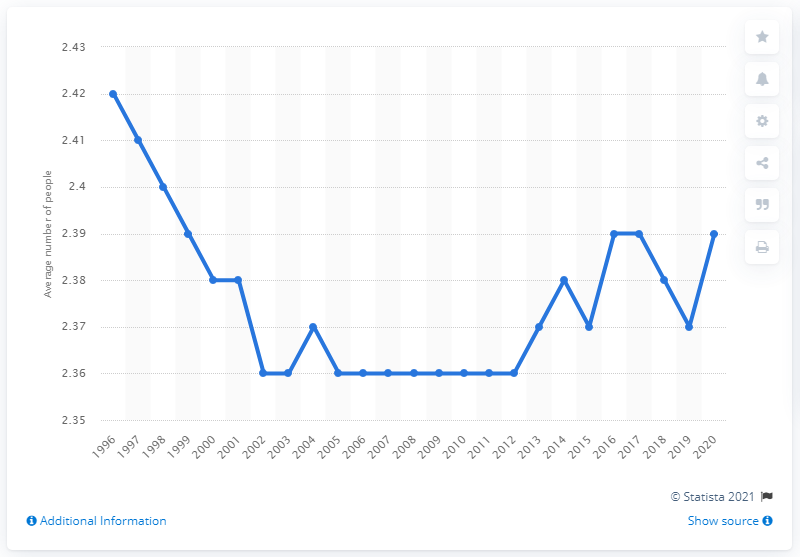Highlight a few significant elements in this photo. In 2004, the average household size dropped to 2.36. In the mid-1990s, the average household size was approximately 2.42 people. In 2020, the average number of people per household in the UK was 2.39. 